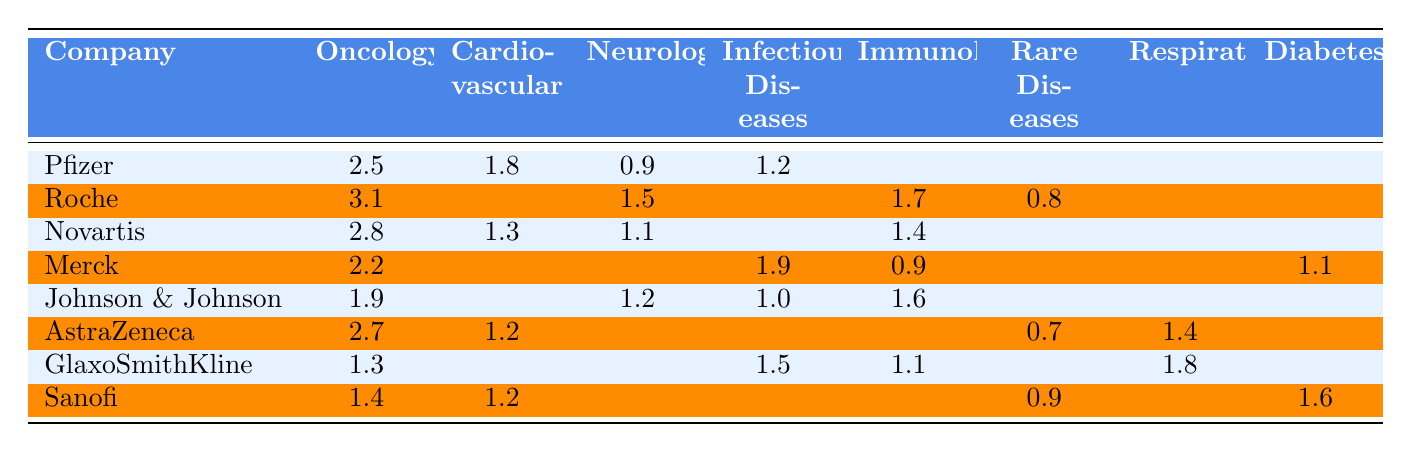What is the total funding provided by Pfizer for Infectious Diseases? According to the table, Pfizer has a funding value of 1.2 for Infectious Diseases. Therefore, the total funding provided by Pfizer for Infectious Diseases is directly taken from that value.
Answer: 1.2 Which company has the highest funding in Oncology? The table shows the funding amounts for Oncology: Pfizer (2.5), Roche (3.1), Novartis (2.8), Merck (2.2), Johnson & Johnson (1.9), AstraZeneca (2.7), GlaxoSmithKline (1.3), and Sanofi (1.4). The highest value is 3.1 from Roche.
Answer: Roche What is the average funding amount for Neurology across all companies? The funding amounts for Neurology are: Pfizer (0.9), Roche (1.5), Novartis (1.1), Merck (not provided), Johnson & Johnson (1.2), AstraZeneca (not provided), GlaxoSmithKline (not provided), and Sanofi (not provided). This gives us three values (0.9, 1.5, 1.1, 1.2). The sum is 4.7, and dividing this by 4 (the number of companies that reported funding) results in an average of 1.175.
Answer: 1.175 Is there any company that funds Rare Diseases? The table shows the funding for Rare Diseases: Roche (0.8), AstraZeneca (0.7), and Sanofi (0.9). Since these companies have non-zero values listed for Rare Diseases, the answer is yes.
Answer: Yes Which therapeutic area has the least funding reported by AstraZeneca? The reported funding amounts for AstraZeneca are for Oncology (2.7), Respiratory (1.4), Cardiovascular (1.2), and Rare Diseases (0.7). The least amount is 0.7 in Rare Diseases.
Answer: Rare Diseases Calculate the total funding for Infectious Diseases across all companies. The funding amounts for Infectious Diseases from the table are: Pfizer (1.2), Roche (not provided), Novartis (not provided), Merck (1.9), Johnson & Johnson (1.0), GlaxoSmithKline (1.5). Listing the provided values gives us a total of 1.2 + 1.9 + 1.0 + 1.5 which equals 5.6.
Answer: 5.6 Which company has lower funding in Immunology than Johnson & Johnson? Johnson & Johnson has 1.6 in Immunology. The companies with corresponding Immunology funding values are Roche (1.7), Novartis (1.4), Merck (0.9), GlaxoSmithKline (1.1), and AstraZeneca (not provided). Among those, Novartis (1.4), Merck (0.9), and GlaxoSmithKline (1.1) have lower funding.
Answer: Novartis, Merck, GlaxoSmithKline What is the total funding in Diabetes by all companies listed? According to the table, the only company that reported funding for Diabetes is Merck (1.1) and Sanofi (1.6). The total funding for Diabetes is 1.1 + 1.6, which totals to 2.7.
Answer: 2.7 Which therapeutic area has the highest total funding from all companies combined? By calculating the sum of the values for each therapeutic area from all companies, we find: Oncology (2.5+3.1+2.8+2.2+1.9+2.7+1.3+1.4) = 17.5, Cardiovascular (1.8+1.3+1.2+1.2)=5.5, Neurology (0.9+1.5+1.1+1.2)=4.7, Infectious Diseases (1.2+1.9+1.0+1.5)=5.6, Immunology (1.7+1.4+0.9+1.6+1.1)=7.9, Rare Diseases (0.8+0.7+0.9)=2.4, Respiratory (1.4+1.8)=3.2, and Diabetes (1.1+1.6)=2.7. The highest total is for Oncology at 17.5.
Answer: Oncology What percentage of the total funding in Oncology is provided by Roche? Total funding for Oncology is 17.5. Roche provides 3.1. Thus the percentage is calculated as (3.1/17.5)*100 ≈ 17.7%.
Answer: 17.7% 